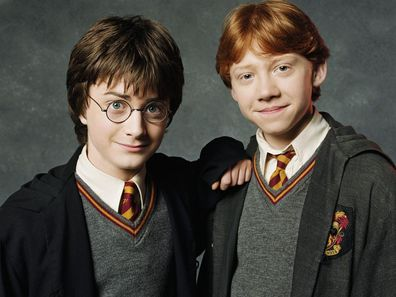Imagine a humorous scenario involving these characters in this image. Imagine Harry and Ron attempting to bake a magical cake in the Hogwarts kitchens. Ron, having never baked before, accidentally adds too many dragon eggs, while Harry struggles with a sentient whisk that refuses to cooperate. The cake batter magically expands and fills the room with enchanted bubbles. Amid the chaos, the house-elf Dobby appears, trying to help, but only ends up wearing the cake batter as a hat. Finally, Hermione arrives, casts a tidy-up spell, and the trio ends up laughing hysterically at the mess they created. Despite the fiasco, they end up enjoying a perfectly conjured feast by the house-elves, complete with a magically delicious cake. 